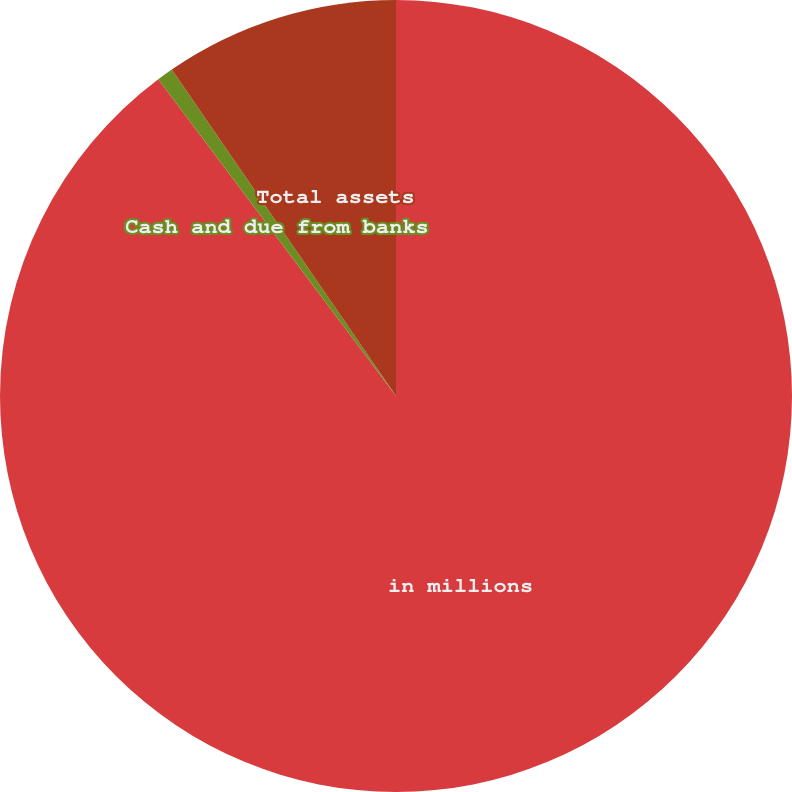Convert chart to OTSL. <chart><loc_0><loc_0><loc_500><loc_500><pie_chart><fcel>in millions<fcel>Cash and due from banks<fcel>Total assets<nl><fcel>89.76%<fcel>0.67%<fcel>9.58%<nl></chart> 